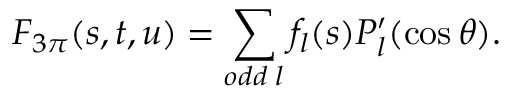<formula> <loc_0><loc_0><loc_500><loc_500>F _ { 3 \pi } ( s , t , u ) = \sum _ { o d d \, l } f _ { l } ( s ) P _ { l } ^ { \prime } ( \cos \theta ) .</formula> 